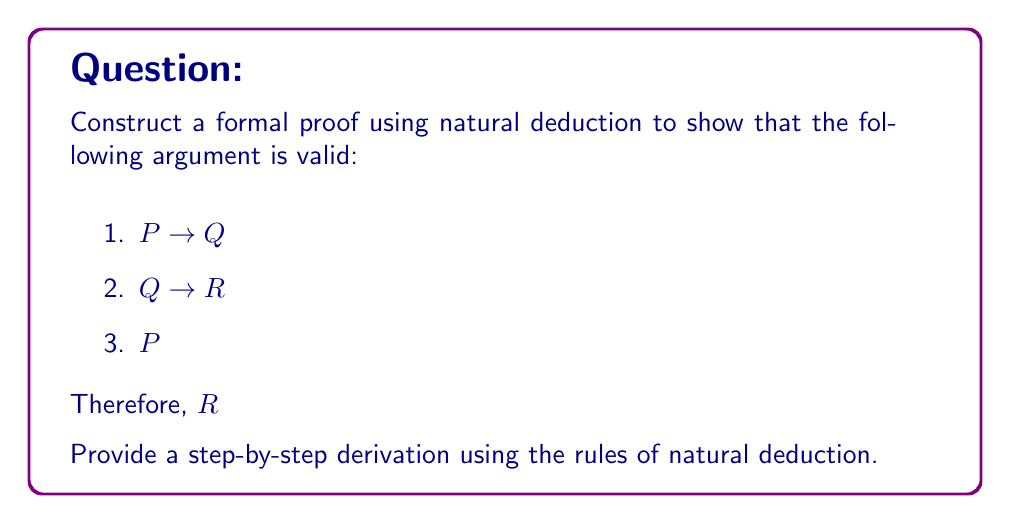Solve this math problem. Let's construct a formal proof using natural deduction to show that the argument is valid. We'll use the given premises and apply the rules of natural deduction to derive the conclusion.

Step 1: List the premises
1. $P \rightarrow Q$ (Given)
2. $Q \rightarrow R$ (Given)
3. $P$ (Given)

Step 2: Apply Modus Ponens to premises 1 and 3
4. $Q$ (Modus Ponens, 1, 3)

Step 3: Apply Modus Ponens to steps 2 and 4
5. $R$ (Modus Ponens, 2, 4)

Explanation of steps:
- In step 4, we use Modus Ponens (MP) on premises 1 and 3. Modus Ponens states that if we have $P \rightarrow Q$ and $P$, we can conclude $Q$.
- In step 5, we use Modus Ponens again, this time on premise 2 and the result from step 4. Since we have $Q \rightarrow R$ and $Q$, we can conclude $R$.

The formal proof can be written as:

$$
\begin{array}{ll}
1. & P \rightarrow Q & \text{(Premise)} \\
2. & Q \rightarrow R & \text{(Premise)} \\
3. & P & \text{(Premise)} \\
4. & Q & \text{(MP 1, 3)} \\
5. & R & \text{(MP 2, 4)}
\end{array}
$$

This completes the formal proof, demonstrating that the conclusion $R$ follows logically from the given premises using natural deduction.
Answer: $R$ (derived through Modus Ponens) 